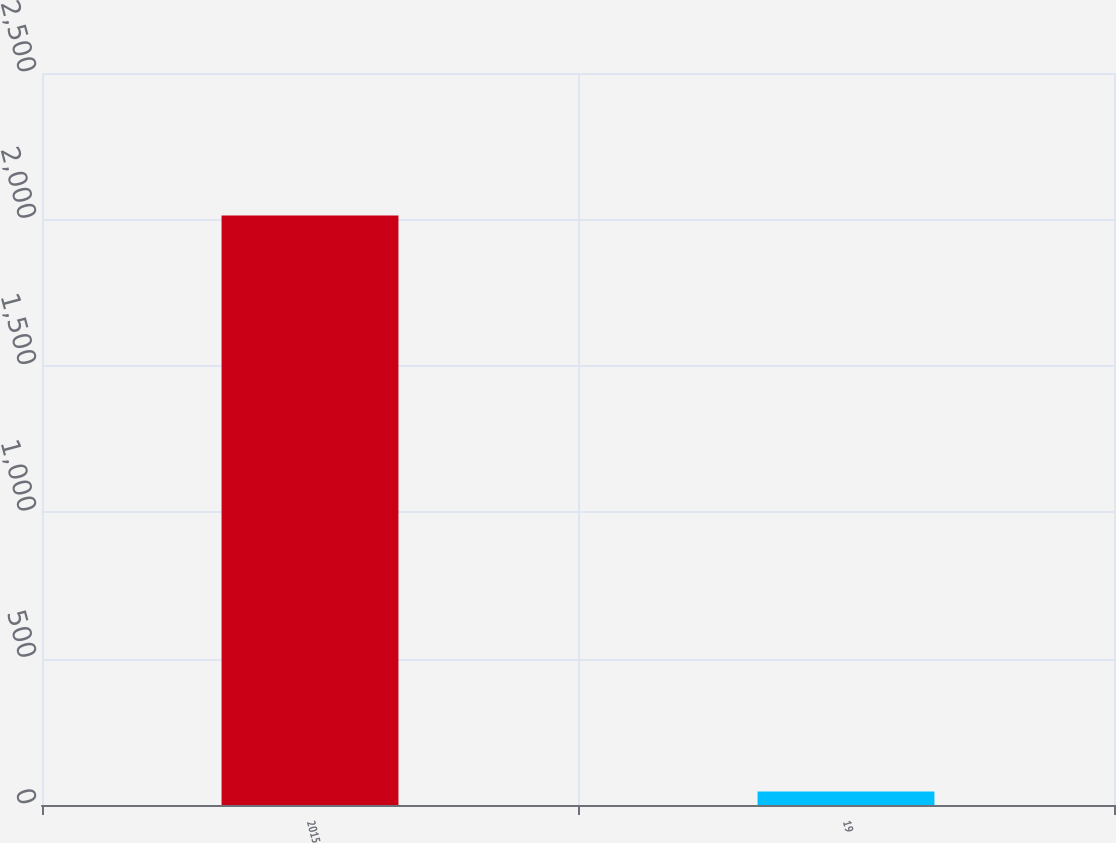Convert chart to OTSL. <chart><loc_0><loc_0><loc_500><loc_500><bar_chart><fcel>2015<fcel>19<nl><fcel>2013<fcel>46<nl></chart> 